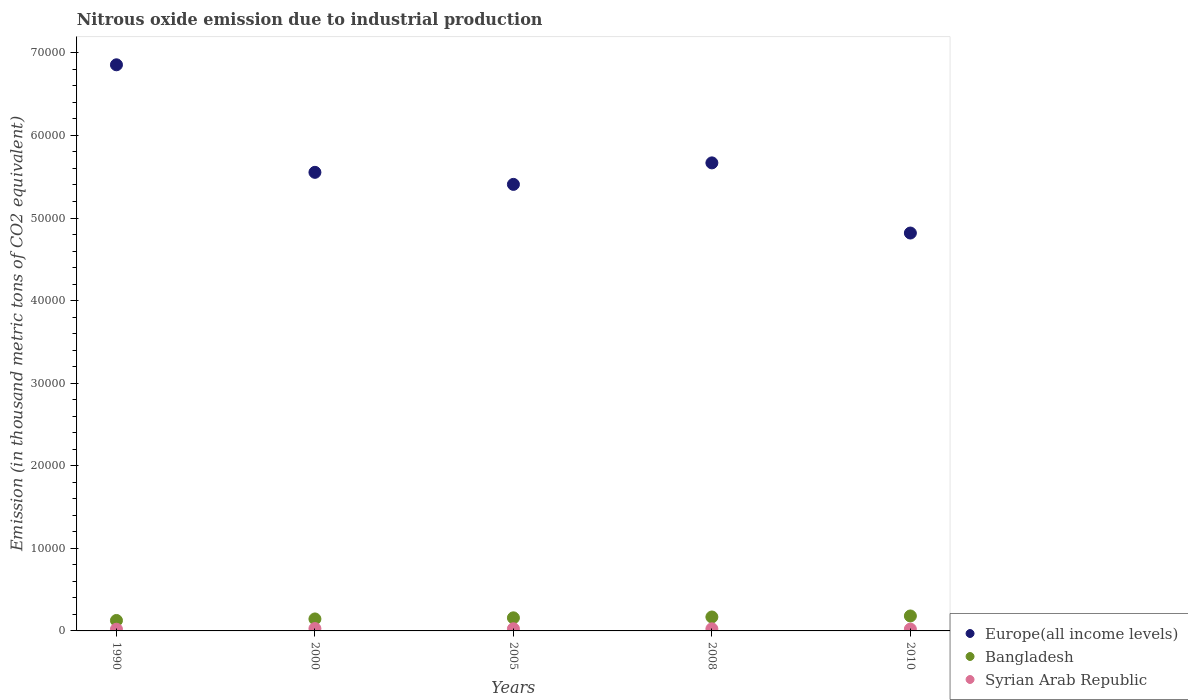Is the number of dotlines equal to the number of legend labels?
Your response must be concise. Yes. What is the amount of nitrous oxide emitted in Syrian Arab Republic in 2008?
Offer a terse response. 251.7. Across all years, what is the maximum amount of nitrous oxide emitted in Bangladesh?
Your response must be concise. 1810.8. Across all years, what is the minimum amount of nitrous oxide emitted in Europe(all income levels)?
Your answer should be very brief. 4.82e+04. What is the total amount of nitrous oxide emitted in Bangladesh in the graph?
Keep it short and to the point. 7798.3. What is the difference between the amount of nitrous oxide emitted in Syrian Arab Republic in 2008 and that in 2010?
Provide a short and direct response. 32.2. What is the difference between the amount of nitrous oxide emitted in Bangladesh in 2000 and the amount of nitrous oxide emitted in Europe(all income levels) in 1990?
Offer a terse response. -6.71e+04. What is the average amount of nitrous oxide emitted in Syrian Arab Republic per year?
Provide a succinct answer. 244.76. In the year 2010, what is the difference between the amount of nitrous oxide emitted in Syrian Arab Republic and amount of nitrous oxide emitted in Bangladesh?
Make the answer very short. -1591.3. In how many years, is the amount of nitrous oxide emitted in Syrian Arab Republic greater than 4000 thousand metric tons?
Keep it short and to the point. 0. What is the ratio of the amount of nitrous oxide emitted in Europe(all income levels) in 1990 to that in 2000?
Keep it short and to the point. 1.23. Is the amount of nitrous oxide emitted in Syrian Arab Republic in 2000 less than that in 2005?
Offer a terse response. No. Is the difference between the amount of nitrous oxide emitted in Syrian Arab Republic in 2000 and 2005 greater than the difference between the amount of nitrous oxide emitted in Bangladesh in 2000 and 2005?
Offer a very short reply. Yes. What is the difference between the highest and the second highest amount of nitrous oxide emitted in Europe(all income levels)?
Your answer should be compact. 1.19e+04. What is the difference between the highest and the lowest amount of nitrous oxide emitted in Syrian Arab Republic?
Give a very brief answer. 76.2. Is the sum of the amount of nitrous oxide emitted in Bangladesh in 2005 and 2008 greater than the maximum amount of nitrous oxide emitted in Europe(all income levels) across all years?
Your answer should be very brief. No. Is it the case that in every year, the sum of the amount of nitrous oxide emitted in Syrian Arab Republic and amount of nitrous oxide emitted in Europe(all income levels)  is greater than the amount of nitrous oxide emitted in Bangladesh?
Give a very brief answer. Yes. Is the amount of nitrous oxide emitted in Bangladesh strictly greater than the amount of nitrous oxide emitted in Syrian Arab Republic over the years?
Ensure brevity in your answer.  Yes. Is the amount of nitrous oxide emitted in Syrian Arab Republic strictly less than the amount of nitrous oxide emitted in Europe(all income levels) over the years?
Make the answer very short. Yes. How many years are there in the graph?
Your response must be concise. 5. What is the difference between two consecutive major ticks on the Y-axis?
Your response must be concise. 10000. Does the graph contain any zero values?
Offer a very short reply. No. Does the graph contain grids?
Provide a succinct answer. No. Where does the legend appear in the graph?
Give a very brief answer. Bottom right. How are the legend labels stacked?
Offer a terse response. Vertical. What is the title of the graph?
Offer a terse response. Nitrous oxide emission due to industrial production. What is the label or title of the Y-axis?
Your response must be concise. Emission (in thousand metric tons of CO2 equivalent). What is the Emission (in thousand metric tons of CO2 equivalent) of Europe(all income levels) in 1990?
Your answer should be compact. 6.86e+04. What is the Emission (in thousand metric tons of CO2 equivalent) of Bangladesh in 1990?
Your answer should be very brief. 1265.7. What is the Emission (in thousand metric tons of CO2 equivalent) in Syrian Arab Republic in 1990?
Your answer should be compact. 207.1. What is the Emission (in thousand metric tons of CO2 equivalent) of Europe(all income levels) in 2000?
Provide a short and direct response. 5.55e+04. What is the Emission (in thousand metric tons of CO2 equivalent) of Bangladesh in 2000?
Offer a terse response. 1450.3. What is the Emission (in thousand metric tons of CO2 equivalent) in Syrian Arab Republic in 2000?
Your response must be concise. 283.3. What is the Emission (in thousand metric tons of CO2 equivalent) in Europe(all income levels) in 2005?
Offer a terse response. 5.41e+04. What is the Emission (in thousand metric tons of CO2 equivalent) in Bangladesh in 2005?
Make the answer very short. 1584.6. What is the Emission (in thousand metric tons of CO2 equivalent) of Syrian Arab Republic in 2005?
Your answer should be compact. 262.2. What is the Emission (in thousand metric tons of CO2 equivalent) of Europe(all income levels) in 2008?
Provide a succinct answer. 5.67e+04. What is the Emission (in thousand metric tons of CO2 equivalent) of Bangladesh in 2008?
Ensure brevity in your answer.  1686.9. What is the Emission (in thousand metric tons of CO2 equivalent) of Syrian Arab Republic in 2008?
Your response must be concise. 251.7. What is the Emission (in thousand metric tons of CO2 equivalent) in Europe(all income levels) in 2010?
Offer a very short reply. 4.82e+04. What is the Emission (in thousand metric tons of CO2 equivalent) of Bangladesh in 2010?
Your answer should be very brief. 1810.8. What is the Emission (in thousand metric tons of CO2 equivalent) in Syrian Arab Republic in 2010?
Provide a short and direct response. 219.5. Across all years, what is the maximum Emission (in thousand metric tons of CO2 equivalent) of Europe(all income levels)?
Give a very brief answer. 6.86e+04. Across all years, what is the maximum Emission (in thousand metric tons of CO2 equivalent) of Bangladesh?
Your response must be concise. 1810.8. Across all years, what is the maximum Emission (in thousand metric tons of CO2 equivalent) in Syrian Arab Republic?
Your response must be concise. 283.3. Across all years, what is the minimum Emission (in thousand metric tons of CO2 equivalent) of Europe(all income levels)?
Offer a very short reply. 4.82e+04. Across all years, what is the minimum Emission (in thousand metric tons of CO2 equivalent) in Bangladesh?
Ensure brevity in your answer.  1265.7. Across all years, what is the minimum Emission (in thousand metric tons of CO2 equivalent) in Syrian Arab Republic?
Keep it short and to the point. 207.1. What is the total Emission (in thousand metric tons of CO2 equivalent) in Europe(all income levels) in the graph?
Your answer should be very brief. 2.83e+05. What is the total Emission (in thousand metric tons of CO2 equivalent) in Bangladesh in the graph?
Your response must be concise. 7798.3. What is the total Emission (in thousand metric tons of CO2 equivalent) in Syrian Arab Republic in the graph?
Offer a terse response. 1223.8. What is the difference between the Emission (in thousand metric tons of CO2 equivalent) in Europe(all income levels) in 1990 and that in 2000?
Your response must be concise. 1.30e+04. What is the difference between the Emission (in thousand metric tons of CO2 equivalent) in Bangladesh in 1990 and that in 2000?
Ensure brevity in your answer.  -184.6. What is the difference between the Emission (in thousand metric tons of CO2 equivalent) in Syrian Arab Republic in 1990 and that in 2000?
Your answer should be compact. -76.2. What is the difference between the Emission (in thousand metric tons of CO2 equivalent) of Europe(all income levels) in 1990 and that in 2005?
Make the answer very short. 1.45e+04. What is the difference between the Emission (in thousand metric tons of CO2 equivalent) of Bangladesh in 1990 and that in 2005?
Your response must be concise. -318.9. What is the difference between the Emission (in thousand metric tons of CO2 equivalent) of Syrian Arab Republic in 1990 and that in 2005?
Offer a terse response. -55.1. What is the difference between the Emission (in thousand metric tons of CO2 equivalent) of Europe(all income levels) in 1990 and that in 2008?
Offer a terse response. 1.19e+04. What is the difference between the Emission (in thousand metric tons of CO2 equivalent) of Bangladesh in 1990 and that in 2008?
Offer a terse response. -421.2. What is the difference between the Emission (in thousand metric tons of CO2 equivalent) in Syrian Arab Republic in 1990 and that in 2008?
Keep it short and to the point. -44.6. What is the difference between the Emission (in thousand metric tons of CO2 equivalent) in Europe(all income levels) in 1990 and that in 2010?
Give a very brief answer. 2.04e+04. What is the difference between the Emission (in thousand metric tons of CO2 equivalent) in Bangladesh in 1990 and that in 2010?
Provide a short and direct response. -545.1. What is the difference between the Emission (in thousand metric tons of CO2 equivalent) in Europe(all income levels) in 2000 and that in 2005?
Provide a short and direct response. 1458.2. What is the difference between the Emission (in thousand metric tons of CO2 equivalent) in Bangladesh in 2000 and that in 2005?
Offer a very short reply. -134.3. What is the difference between the Emission (in thousand metric tons of CO2 equivalent) of Syrian Arab Republic in 2000 and that in 2005?
Provide a succinct answer. 21.1. What is the difference between the Emission (in thousand metric tons of CO2 equivalent) in Europe(all income levels) in 2000 and that in 2008?
Your response must be concise. -1145.4. What is the difference between the Emission (in thousand metric tons of CO2 equivalent) of Bangladesh in 2000 and that in 2008?
Your response must be concise. -236.6. What is the difference between the Emission (in thousand metric tons of CO2 equivalent) of Syrian Arab Republic in 2000 and that in 2008?
Provide a short and direct response. 31.6. What is the difference between the Emission (in thousand metric tons of CO2 equivalent) in Europe(all income levels) in 2000 and that in 2010?
Give a very brief answer. 7349.4. What is the difference between the Emission (in thousand metric tons of CO2 equivalent) in Bangladesh in 2000 and that in 2010?
Give a very brief answer. -360.5. What is the difference between the Emission (in thousand metric tons of CO2 equivalent) in Syrian Arab Republic in 2000 and that in 2010?
Your answer should be compact. 63.8. What is the difference between the Emission (in thousand metric tons of CO2 equivalent) in Europe(all income levels) in 2005 and that in 2008?
Provide a short and direct response. -2603.6. What is the difference between the Emission (in thousand metric tons of CO2 equivalent) in Bangladesh in 2005 and that in 2008?
Offer a terse response. -102.3. What is the difference between the Emission (in thousand metric tons of CO2 equivalent) in Europe(all income levels) in 2005 and that in 2010?
Your answer should be very brief. 5891.2. What is the difference between the Emission (in thousand metric tons of CO2 equivalent) of Bangladesh in 2005 and that in 2010?
Provide a short and direct response. -226.2. What is the difference between the Emission (in thousand metric tons of CO2 equivalent) of Syrian Arab Republic in 2005 and that in 2010?
Provide a short and direct response. 42.7. What is the difference between the Emission (in thousand metric tons of CO2 equivalent) of Europe(all income levels) in 2008 and that in 2010?
Your answer should be compact. 8494.8. What is the difference between the Emission (in thousand metric tons of CO2 equivalent) of Bangladesh in 2008 and that in 2010?
Make the answer very short. -123.9. What is the difference between the Emission (in thousand metric tons of CO2 equivalent) of Syrian Arab Republic in 2008 and that in 2010?
Your answer should be compact. 32.2. What is the difference between the Emission (in thousand metric tons of CO2 equivalent) of Europe(all income levels) in 1990 and the Emission (in thousand metric tons of CO2 equivalent) of Bangladesh in 2000?
Your answer should be very brief. 6.71e+04. What is the difference between the Emission (in thousand metric tons of CO2 equivalent) of Europe(all income levels) in 1990 and the Emission (in thousand metric tons of CO2 equivalent) of Syrian Arab Republic in 2000?
Make the answer very short. 6.83e+04. What is the difference between the Emission (in thousand metric tons of CO2 equivalent) in Bangladesh in 1990 and the Emission (in thousand metric tons of CO2 equivalent) in Syrian Arab Republic in 2000?
Offer a very short reply. 982.4. What is the difference between the Emission (in thousand metric tons of CO2 equivalent) in Europe(all income levels) in 1990 and the Emission (in thousand metric tons of CO2 equivalent) in Bangladesh in 2005?
Ensure brevity in your answer.  6.70e+04. What is the difference between the Emission (in thousand metric tons of CO2 equivalent) in Europe(all income levels) in 1990 and the Emission (in thousand metric tons of CO2 equivalent) in Syrian Arab Republic in 2005?
Your answer should be compact. 6.83e+04. What is the difference between the Emission (in thousand metric tons of CO2 equivalent) in Bangladesh in 1990 and the Emission (in thousand metric tons of CO2 equivalent) in Syrian Arab Republic in 2005?
Ensure brevity in your answer.  1003.5. What is the difference between the Emission (in thousand metric tons of CO2 equivalent) in Europe(all income levels) in 1990 and the Emission (in thousand metric tons of CO2 equivalent) in Bangladesh in 2008?
Your response must be concise. 6.69e+04. What is the difference between the Emission (in thousand metric tons of CO2 equivalent) of Europe(all income levels) in 1990 and the Emission (in thousand metric tons of CO2 equivalent) of Syrian Arab Republic in 2008?
Your answer should be very brief. 6.83e+04. What is the difference between the Emission (in thousand metric tons of CO2 equivalent) of Bangladesh in 1990 and the Emission (in thousand metric tons of CO2 equivalent) of Syrian Arab Republic in 2008?
Keep it short and to the point. 1014. What is the difference between the Emission (in thousand metric tons of CO2 equivalent) in Europe(all income levels) in 1990 and the Emission (in thousand metric tons of CO2 equivalent) in Bangladesh in 2010?
Offer a terse response. 6.67e+04. What is the difference between the Emission (in thousand metric tons of CO2 equivalent) of Europe(all income levels) in 1990 and the Emission (in thousand metric tons of CO2 equivalent) of Syrian Arab Republic in 2010?
Ensure brevity in your answer.  6.83e+04. What is the difference between the Emission (in thousand metric tons of CO2 equivalent) of Bangladesh in 1990 and the Emission (in thousand metric tons of CO2 equivalent) of Syrian Arab Republic in 2010?
Your answer should be compact. 1046.2. What is the difference between the Emission (in thousand metric tons of CO2 equivalent) of Europe(all income levels) in 2000 and the Emission (in thousand metric tons of CO2 equivalent) of Bangladesh in 2005?
Provide a short and direct response. 5.39e+04. What is the difference between the Emission (in thousand metric tons of CO2 equivalent) of Europe(all income levels) in 2000 and the Emission (in thousand metric tons of CO2 equivalent) of Syrian Arab Republic in 2005?
Provide a short and direct response. 5.53e+04. What is the difference between the Emission (in thousand metric tons of CO2 equivalent) of Bangladesh in 2000 and the Emission (in thousand metric tons of CO2 equivalent) of Syrian Arab Republic in 2005?
Give a very brief answer. 1188.1. What is the difference between the Emission (in thousand metric tons of CO2 equivalent) of Europe(all income levels) in 2000 and the Emission (in thousand metric tons of CO2 equivalent) of Bangladesh in 2008?
Your answer should be compact. 5.38e+04. What is the difference between the Emission (in thousand metric tons of CO2 equivalent) of Europe(all income levels) in 2000 and the Emission (in thousand metric tons of CO2 equivalent) of Syrian Arab Republic in 2008?
Provide a short and direct response. 5.53e+04. What is the difference between the Emission (in thousand metric tons of CO2 equivalent) in Bangladesh in 2000 and the Emission (in thousand metric tons of CO2 equivalent) in Syrian Arab Republic in 2008?
Your answer should be very brief. 1198.6. What is the difference between the Emission (in thousand metric tons of CO2 equivalent) in Europe(all income levels) in 2000 and the Emission (in thousand metric tons of CO2 equivalent) in Bangladesh in 2010?
Provide a short and direct response. 5.37e+04. What is the difference between the Emission (in thousand metric tons of CO2 equivalent) of Europe(all income levels) in 2000 and the Emission (in thousand metric tons of CO2 equivalent) of Syrian Arab Republic in 2010?
Make the answer very short. 5.53e+04. What is the difference between the Emission (in thousand metric tons of CO2 equivalent) of Bangladesh in 2000 and the Emission (in thousand metric tons of CO2 equivalent) of Syrian Arab Republic in 2010?
Offer a very short reply. 1230.8. What is the difference between the Emission (in thousand metric tons of CO2 equivalent) in Europe(all income levels) in 2005 and the Emission (in thousand metric tons of CO2 equivalent) in Bangladesh in 2008?
Your answer should be compact. 5.24e+04. What is the difference between the Emission (in thousand metric tons of CO2 equivalent) of Europe(all income levels) in 2005 and the Emission (in thousand metric tons of CO2 equivalent) of Syrian Arab Republic in 2008?
Your answer should be very brief. 5.38e+04. What is the difference between the Emission (in thousand metric tons of CO2 equivalent) in Bangladesh in 2005 and the Emission (in thousand metric tons of CO2 equivalent) in Syrian Arab Republic in 2008?
Provide a succinct answer. 1332.9. What is the difference between the Emission (in thousand metric tons of CO2 equivalent) in Europe(all income levels) in 2005 and the Emission (in thousand metric tons of CO2 equivalent) in Bangladesh in 2010?
Your answer should be compact. 5.23e+04. What is the difference between the Emission (in thousand metric tons of CO2 equivalent) of Europe(all income levels) in 2005 and the Emission (in thousand metric tons of CO2 equivalent) of Syrian Arab Republic in 2010?
Your answer should be very brief. 5.39e+04. What is the difference between the Emission (in thousand metric tons of CO2 equivalent) of Bangladesh in 2005 and the Emission (in thousand metric tons of CO2 equivalent) of Syrian Arab Republic in 2010?
Ensure brevity in your answer.  1365.1. What is the difference between the Emission (in thousand metric tons of CO2 equivalent) in Europe(all income levels) in 2008 and the Emission (in thousand metric tons of CO2 equivalent) in Bangladesh in 2010?
Your answer should be very brief. 5.49e+04. What is the difference between the Emission (in thousand metric tons of CO2 equivalent) in Europe(all income levels) in 2008 and the Emission (in thousand metric tons of CO2 equivalent) in Syrian Arab Republic in 2010?
Ensure brevity in your answer.  5.65e+04. What is the difference between the Emission (in thousand metric tons of CO2 equivalent) in Bangladesh in 2008 and the Emission (in thousand metric tons of CO2 equivalent) in Syrian Arab Republic in 2010?
Keep it short and to the point. 1467.4. What is the average Emission (in thousand metric tons of CO2 equivalent) in Europe(all income levels) per year?
Provide a succinct answer. 5.66e+04. What is the average Emission (in thousand metric tons of CO2 equivalent) in Bangladesh per year?
Provide a short and direct response. 1559.66. What is the average Emission (in thousand metric tons of CO2 equivalent) in Syrian Arab Republic per year?
Give a very brief answer. 244.76. In the year 1990, what is the difference between the Emission (in thousand metric tons of CO2 equivalent) in Europe(all income levels) and Emission (in thousand metric tons of CO2 equivalent) in Bangladesh?
Your answer should be very brief. 6.73e+04. In the year 1990, what is the difference between the Emission (in thousand metric tons of CO2 equivalent) in Europe(all income levels) and Emission (in thousand metric tons of CO2 equivalent) in Syrian Arab Republic?
Ensure brevity in your answer.  6.83e+04. In the year 1990, what is the difference between the Emission (in thousand metric tons of CO2 equivalent) of Bangladesh and Emission (in thousand metric tons of CO2 equivalent) of Syrian Arab Republic?
Give a very brief answer. 1058.6. In the year 2000, what is the difference between the Emission (in thousand metric tons of CO2 equivalent) of Europe(all income levels) and Emission (in thousand metric tons of CO2 equivalent) of Bangladesh?
Your answer should be very brief. 5.41e+04. In the year 2000, what is the difference between the Emission (in thousand metric tons of CO2 equivalent) of Europe(all income levels) and Emission (in thousand metric tons of CO2 equivalent) of Syrian Arab Republic?
Your response must be concise. 5.52e+04. In the year 2000, what is the difference between the Emission (in thousand metric tons of CO2 equivalent) of Bangladesh and Emission (in thousand metric tons of CO2 equivalent) of Syrian Arab Republic?
Make the answer very short. 1167. In the year 2005, what is the difference between the Emission (in thousand metric tons of CO2 equivalent) in Europe(all income levels) and Emission (in thousand metric tons of CO2 equivalent) in Bangladesh?
Give a very brief answer. 5.25e+04. In the year 2005, what is the difference between the Emission (in thousand metric tons of CO2 equivalent) of Europe(all income levels) and Emission (in thousand metric tons of CO2 equivalent) of Syrian Arab Republic?
Offer a very short reply. 5.38e+04. In the year 2005, what is the difference between the Emission (in thousand metric tons of CO2 equivalent) of Bangladesh and Emission (in thousand metric tons of CO2 equivalent) of Syrian Arab Republic?
Provide a short and direct response. 1322.4. In the year 2008, what is the difference between the Emission (in thousand metric tons of CO2 equivalent) of Europe(all income levels) and Emission (in thousand metric tons of CO2 equivalent) of Bangladesh?
Provide a short and direct response. 5.50e+04. In the year 2008, what is the difference between the Emission (in thousand metric tons of CO2 equivalent) in Europe(all income levels) and Emission (in thousand metric tons of CO2 equivalent) in Syrian Arab Republic?
Your answer should be compact. 5.64e+04. In the year 2008, what is the difference between the Emission (in thousand metric tons of CO2 equivalent) in Bangladesh and Emission (in thousand metric tons of CO2 equivalent) in Syrian Arab Republic?
Your response must be concise. 1435.2. In the year 2010, what is the difference between the Emission (in thousand metric tons of CO2 equivalent) of Europe(all income levels) and Emission (in thousand metric tons of CO2 equivalent) of Bangladesh?
Keep it short and to the point. 4.64e+04. In the year 2010, what is the difference between the Emission (in thousand metric tons of CO2 equivalent) of Europe(all income levels) and Emission (in thousand metric tons of CO2 equivalent) of Syrian Arab Republic?
Your answer should be very brief. 4.80e+04. In the year 2010, what is the difference between the Emission (in thousand metric tons of CO2 equivalent) of Bangladesh and Emission (in thousand metric tons of CO2 equivalent) of Syrian Arab Republic?
Your answer should be very brief. 1591.3. What is the ratio of the Emission (in thousand metric tons of CO2 equivalent) in Europe(all income levels) in 1990 to that in 2000?
Provide a short and direct response. 1.23. What is the ratio of the Emission (in thousand metric tons of CO2 equivalent) in Bangladesh in 1990 to that in 2000?
Your response must be concise. 0.87. What is the ratio of the Emission (in thousand metric tons of CO2 equivalent) in Syrian Arab Republic in 1990 to that in 2000?
Your response must be concise. 0.73. What is the ratio of the Emission (in thousand metric tons of CO2 equivalent) of Europe(all income levels) in 1990 to that in 2005?
Provide a short and direct response. 1.27. What is the ratio of the Emission (in thousand metric tons of CO2 equivalent) of Bangladesh in 1990 to that in 2005?
Provide a succinct answer. 0.8. What is the ratio of the Emission (in thousand metric tons of CO2 equivalent) in Syrian Arab Republic in 1990 to that in 2005?
Keep it short and to the point. 0.79. What is the ratio of the Emission (in thousand metric tons of CO2 equivalent) of Europe(all income levels) in 1990 to that in 2008?
Your response must be concise. 1.21. What is the ratio of the Emission (in thousand metric tons of CO2 equivalent) of Bangladesh in 1990 to that in 2008?
Keep it short and to the point. 0.75. What is the ratio of the Emission (in thousand metric tons of CO2 equivalent) of Syrian Arab Republic in 1990 to that in 2008?
Your answer should be compact. 0.82. What is the ratio of the Emission (in thousand metric tons of CO2 equivalent) in Europe(all income levels) in 1990 to that in 2010?
Give a very brief answer. 1.42. What is the ratio of the Emission (in thousand metric tons of CO2 equivalent) of Bangladesh in 1990 to that in 2010?
Keep it short and to the point. 0.7. What is the ratio of the Emission (in thousand metric tons of CO2 equivalent) in Syrian Arab Republic in 1990 to that in 2010?
Offer a very short reply. 0.94. What is the ratio of the Emission (in thousand metric tons of CO2 equivalent) in Bangladesh in 2000 to that in 2005?
Provide a short and direct response. 0.92. What is the ratio of the Emission (in thousand metric tons of CO2 equivalent) in Syrian Arab Republic in 2000 to that in 2005?
Make the answer very short. 1.08. What is the ratio of the Emission (in thousand metric tons of CO2 equivalent) in Europe(all income levels) in 2000 to that in 2008?
Keep it short and to the point. 0.98. What is the ratio of the Emission (in thousand metric tons of CO2 equivalent) in Bangladesh in 2000 to that in 2008?
Offer a terse response. 0.86. What is the ratio of the Emission (in thousand metric tons of CO2 equivalent) of Syrian Arab Republic in 2000 to that in 2008?
Your response must be concise. 1.13. What is the ratio of the Emission (in thousand metric tons of CO2 equivalent) of Europe(all income levels) in 2000 to that in 2010?
Ensure brevity in your answer.  1.15. What is the ratio of the Emission (in thousand metric tons of CO2 equivalent) of Bangladesh in 2000 to that in 2010?
Your answer should be compact. 0.8. What is the ratio of the Emission (in thousand metric tons of CO2 equivalent) in Syrian Arab Republic in 2000 to that in 2010?
Give a very brief answer. 1.29. What is the ratio of the Emission (in thousand metric tons of CO2 equivalent) in Europe(all income levels) in 2005 to that in 2008?
Ensure brevity in your answer.  0.95. What is the ratio of the Emission (in thousand metric tons of CO2 equivalent) of Bangladesh in 2005 to that in 2008?
Offer a terse response. 0.94. What is the ratio of the Emission (in thousand metric tons of CO2 equivalent) in Syrian Arab Republic in 2005 to that in 2008?
Ensure brevity in your answer.  1.04. What is the ratio of the Emission (in thousand metric tons of CO2 equivalent) in Europe(all income levels) in 2005 to that in 2010?
Offer a terse response. 1.12. What is the ratio of the Emission (in thousand metric tons of CO2 equivalent) of Bangladesh in 2005 to that in 2010?
Provide a succinct answer. 0.88. What is the ratio of the Emission (in thousand metric tons of CO2 equivalent) of Syrian Arab Republic in 2005 to that in 2010?
Offer a terse response. 1.19. What is the ratio of the Emission (in thousand metric tons of CO2 equivalent) in Europe(all income levels) in 2008 to that in 2010?
Provide a succinct answer. 1.18. What is the ratio of the Emission (in thousand metric tons of CO2 equivalent) in Bangladesh in 2008 to that in 2010?
Your answer should be compact. 0.93. What is the ratio of the Emission (in thousand metric tons of CO2 equivalent) of Syrian Arab Republic in 2008 to that in 2010?
Your answer should be very brief. 1.15. What is the difference between the highest and the second highest Emission (in thousand metric tons of CO2 equivalent) in Europe(all income levels)?
Provide a short and direct response. 1.19e+04. What is the difference between the highest and the second highest Emission (in thousand metric tons of CO2 equivalent) of Bangladesh?
Provide a succinct answer. 123.9. What is the difference between the highest and the second highest Emission (in thousand metric tons of CO2 equivalent) of Syrian Arab Republic?
Give a very brief answer. 21.1. What is the difference between the highest and the lowest Emission (in thousand metric tons of CO2 equivalent) in Europe(all income levels)?
Ensure brevity in your answer.  2.04e+04. What is the difference between the highest and the lowest Emission (in thousand metric tons of CO2 equivalent) in Bangladesh?
Keep it short and to the point. 545.1. What is the difference between the highest and the lowest Emission (in thousand metric tons of CO2 equivalent) of Syrian Arab Republic?
Offer a terse response. 76.2. 